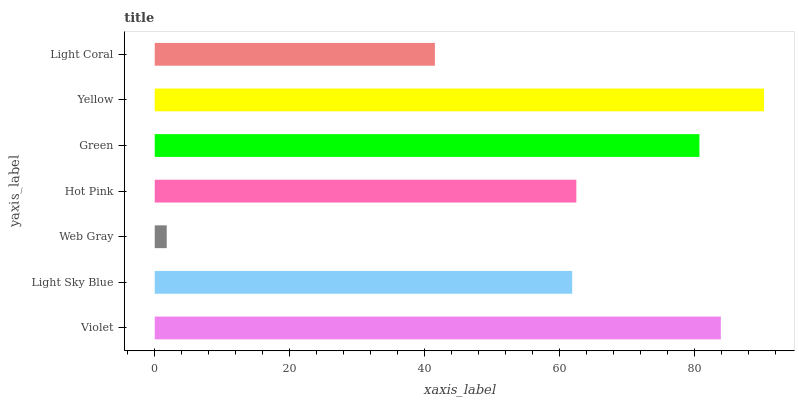Is Web Gray the minimum?
Answer yes or no. Yes. Is Yellow the maximum?
Answer yes or no. Yes. Is Light Sky Blue the minimum?
Answer yes or no. No. Is Light Sky Blue the maximum?
Answer yes or no. No. Is Violet greater than Light Sky Blue?
Answer yes or no. Yes. Is Light Sky Blue less than Violet?
Answer yes or no. Yes. Is Light Sky Blue greater than Violet?
Answer yes or no. No. Is Violet less than Light Sky Blue?
Answer yes or no. No. Is Hot Pink the high median?
Answer yes or no. Yes. Is Hot Pink the low median?
Answer yes or no. Yes. Is Web Gray the high median?
Answer yes or no. No. Is Violet the low median?
Answer yes or no. No. 